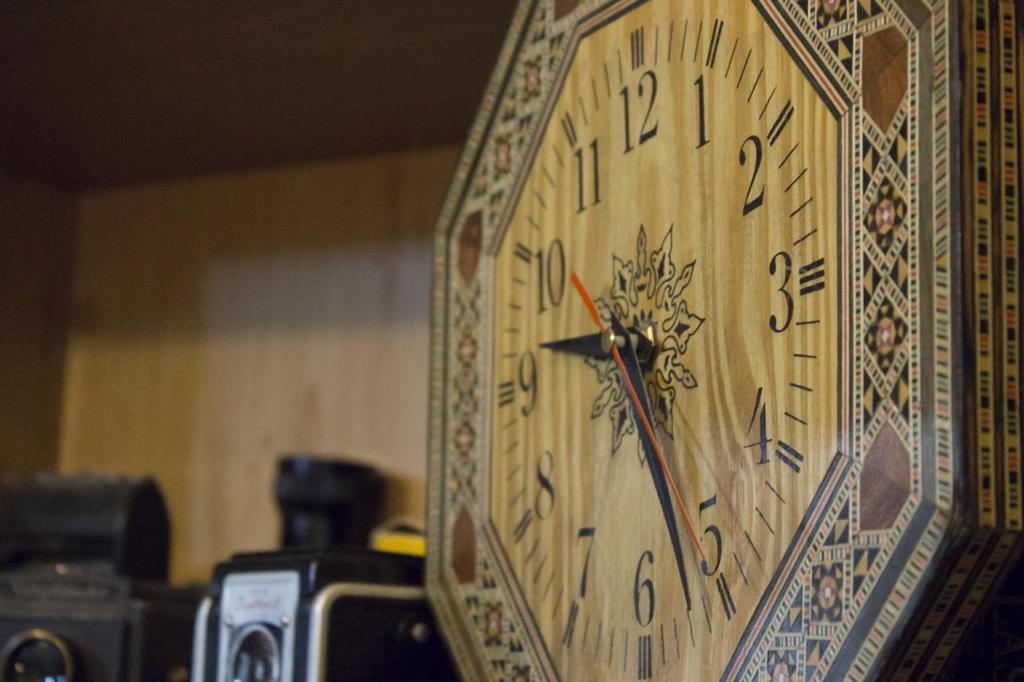What´s the highest number of the clock?
Give a very brief answer. 12. 